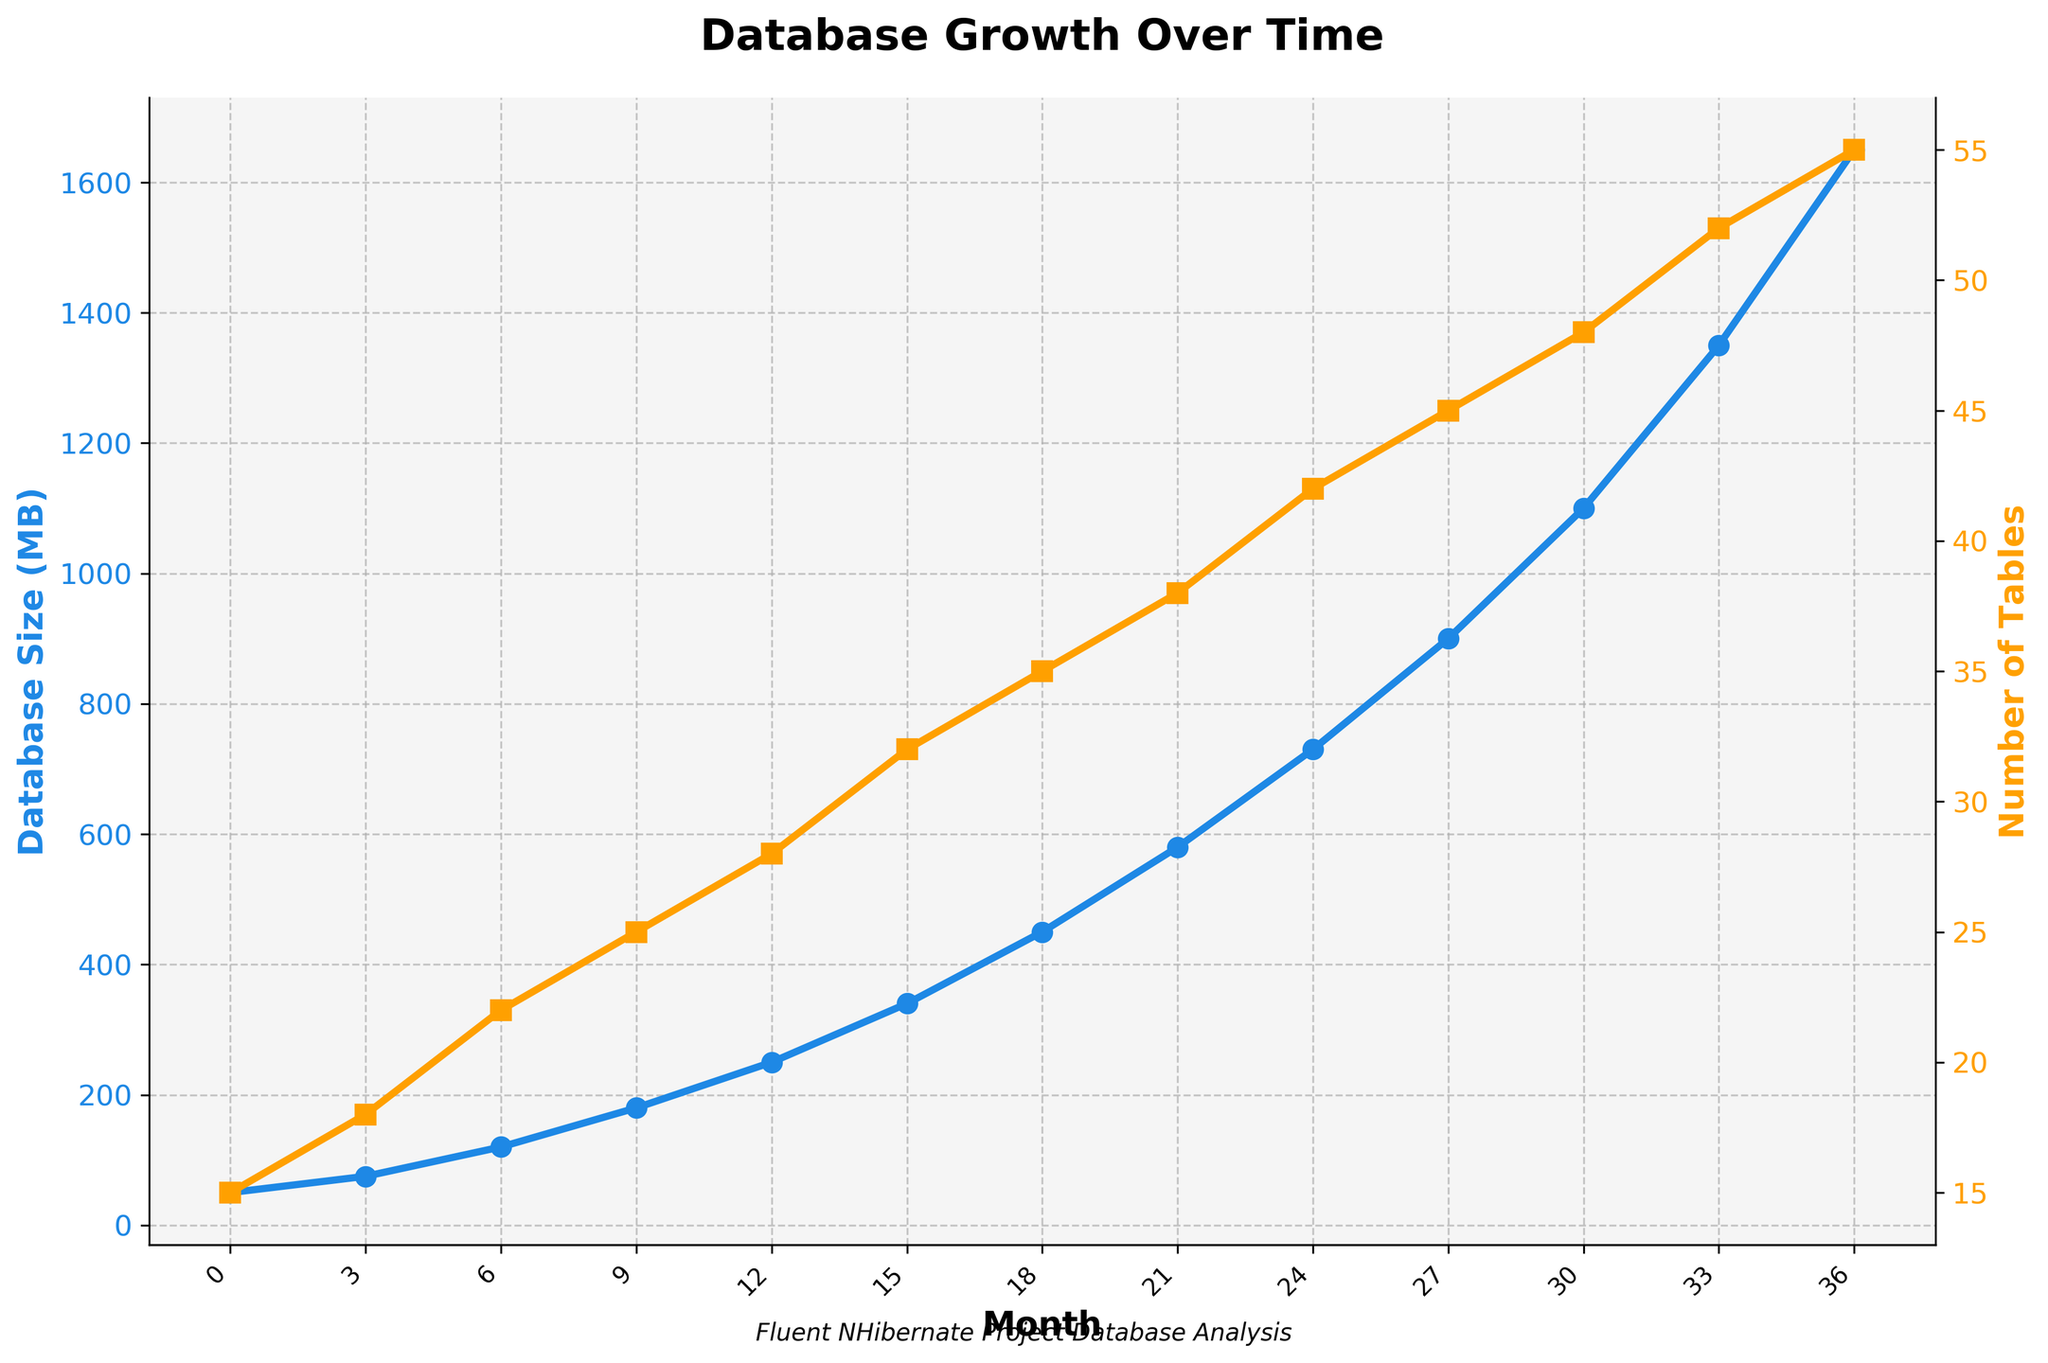What is the database size at month 15? Look at the x-axis for the month 15, then trace upwards to the blue line representing the database size. The value at this point is 340MB.
Answer: 340MB How many tables were added between month 9 and month 18? First, identify the number of tables at month 9, which is 25. Then identify the number at month 18, which is 35. The difference between these values is 35 - 25 = 10.
Answer: 10 Which month shows the steepest increase in database size? By visually inspecting the blue line, the steepest increase has occurred between months 33 and 36 where the line has the sharpest upward slope.
Answer: Between months 33 and 36 What is the total increase in the number of tables from the beginning to the end of the chart? The number of tables in month 0 is 15 and in month 36 is 55. The increase is calculated by subtracting the initial value from the final value: 55 - 15 = 40.
Answer: 40 How does the increase in database size compare to the increase in the number of tables over the entire period? Calculate the increase in database size (1650MB - 50MB = 1600MB) and the increase in number of tables (55 - 15 = 40). The database size has increased by 1600MB, while the number of tables has increased by 40.
Answer: Database size increased significantly more than the number of tables Which curve is represented by the yellow color? The yellow line corresponds to the y-axis on the right, labeled "Number of Tables".
Answer: Number of Tables How much did the database size grow in the first 12 months? The database size at month 12 is 250MB and at month 0 is 50MB. The growth is 250MB - 50MB = 200MB.
Answer: 200MB At what month do both the database size and number of tables rise to roughly halfway of their final value? The final database size is 1650MB and halfway is roughly 825MB. This occurs around month 24. Similarly, the final number of tables is 55, and halfway is around 27.5. This occurs around month 24.
Answer: Around month 24 How many months did it take for the database size to exceed 1000MB? Look for the blue line, and identify the month at which it crosses the 1000MB value on the y-axis. This occurs at month 30.
Answer: 30 What is the ratio of database size to the number of tables at month 36? The database size at month 36 is 1650MB, and the number of tables is 55. The ratio is calculated as 1650 / 55 = 30.
Answer: 30 